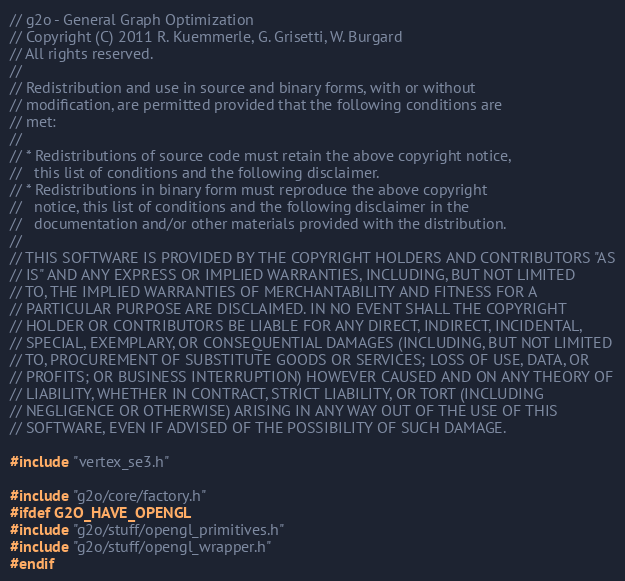<code> <loc_0><loc_0><loc_500><loc_500><_C++_>// g2o - General Graph Optimization
// Copyright (C) 2011 R. Kuemmerle, G. Grisetti, W. Burgard
// All rights reserved.
//
// Redistribution and use in source and binary forms, with or without
// modification, are permitted provided that the following conditions are
// met:
//
// * Redistributions of source code must retain the above copyright notice,
//   this list of conditions and the following disclaimer.
// * Redistributions in binary form must reproduce the above copyright
//   notice, this list of conditions and the following disclaimer in the
//   documentation and/or other materials provided with the distribution.
//
// THIS SOFTWARE IS PROVIDED BY THE COPYRIGHT HOLDERS AND CONTRIBUTORS "AS
// IS" AND ANY EXPRESS OR IMPLIED WARRANTIES, INCLUDING, BUT NOT LIMITED
// TO, THE IMPLIED WARRANTIES OF MERCHANTABILITY AND FITNESS FOR A
// PARTICULAR PURPOSE ARE DISCLAIMED. IN NO EVENT SHALL THE COPYRIGHT
// HOLDER OR CONTRIBUTORS BE LIABLE FOR ANY DIRECT, INDIRECT, INCIDENTAL,
// SPECIAL, EXEMPLARY, OR CONSEQUENTIAL DAMAGES (INCLUDING, BUT NOT LIMITED
// TO, PROCUREMENT OF SUBSTITUTE GOODS OR SERVICES; LOSS OF USE, DATA, OR
// PROFITS; OR BUSINESS INTERRUPTION) HOWEVER CAUSED AND ON ANY THEORY OF
// LIABILITY, WHETHER IN CONTRACT, STRICT LIABILITY, OR TORT (INCLUDING
// NEGLIGENCE OR OTHERWISE) ARISING IN ANY WAY OUT OF THE USE OF THIS
// SOFTWARE, EVEN IF ADVISED OF THE POSSIBILITY OF SUCH DAMAGE.

#include "vertex_se3.h"

#include "g2o/core/factory.h"
#ifdef G2O_HAVE_OPENGL
#include "g2o/stuff/opengl_primitives.h"
#include "g2o/stuff/opengl_wrapper.h"
#endif
</code> 